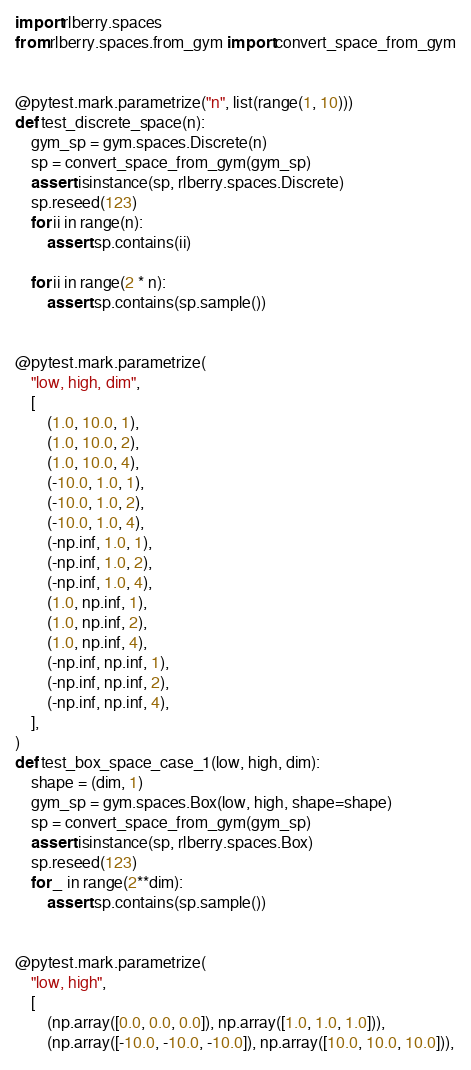<code> <loc_0><loc_0><loc_500><loc_500><_Python_>import rlberry.spaces
from rlberry.spaces.from_gym import convert_space_from_gym


@pytest.mark.parametrize("n", list(range(1, 10)))
def test_discrete_space(n):
    gym_sp = gym.spaces.Discrete(n)
    sp = convert_space_from_gym(gym_sp)
    assert isinstance(sp, rlberry.spaces.Discrete)
    sp.reseed(123)
    for ii in range(n):
        assert sp.contains(ii)

    for ii in range(2 * n):
        assert sp.contains(sp.sample())


@pytest.mark.parametrize(
    "low, high, dim",
    [
        (1.0, 10.0, 1),
        (1.0, 10.0, 2),
        (1.0, 10.0, 4),
        (-10.0, 1.0, 1),
        (-10.0, 1.0, 2),
        (-10.0, 1.0, 4),
        (-np.inf, 1.0, 1),
        (-np.inf, 1.0, 2),
        (-np.inf, 1.0, 4),
        (1.0, np.inf, 1),
        (1.0, np.inf, 2),
        (1.0, np.inf, 4),
        (-np.inf, np.inf, 1),
        (-np.inf, np.inf, 2),
        (-np.inf, np.inf, 4),
    ],
)
def test_box_space_case_1(low, high, dim):
    shape = (dim, 1)
    gym_sp = gym.spaces.Box(low, high, shape=shape)
    sp = convert_space_from_gym(gym_sp)
    assert isinstance(sp, rlberry.spaces.Box)
    sp.reseed(123)
    for _ in range(2**dim):
        assert sp.contains(sp.sample())


@pytest.mark.parametrize(
    "low, high",
    [
        (np.array([0.0, 0.0, 0.0]), np.array([1.0, 1.0, 1.0])),
        (np.array([-10.0, -10.0, -10.0]), np.array([10.0, 10.0, 10.0])),</code> 